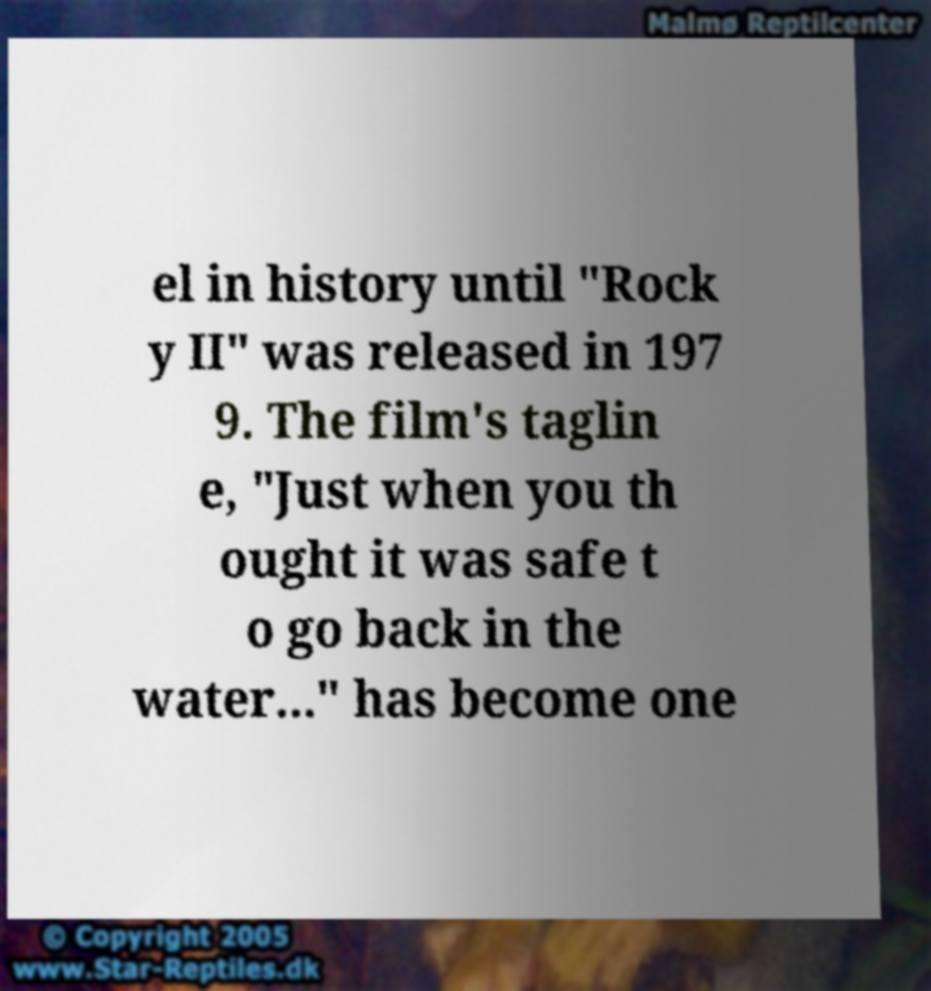Could you extract and type out the text from this image? el in history until "Rock y II" was released in 197 9. The film's taglin e, "Just when you th ought it was safe t o go back in the water..." has become one 